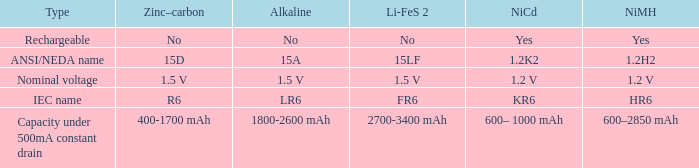What is Li-FeS 2, when Type is Nominal Voltage? 1.5 V. 